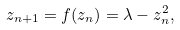Convert formula to latex. <formula><loc_0><loc_0><loc_500><loc_500>z _ { n + 1 } = f ( z _ { n } ) = \lambda - z _ { n } ^ { 2 } ,</formula> 